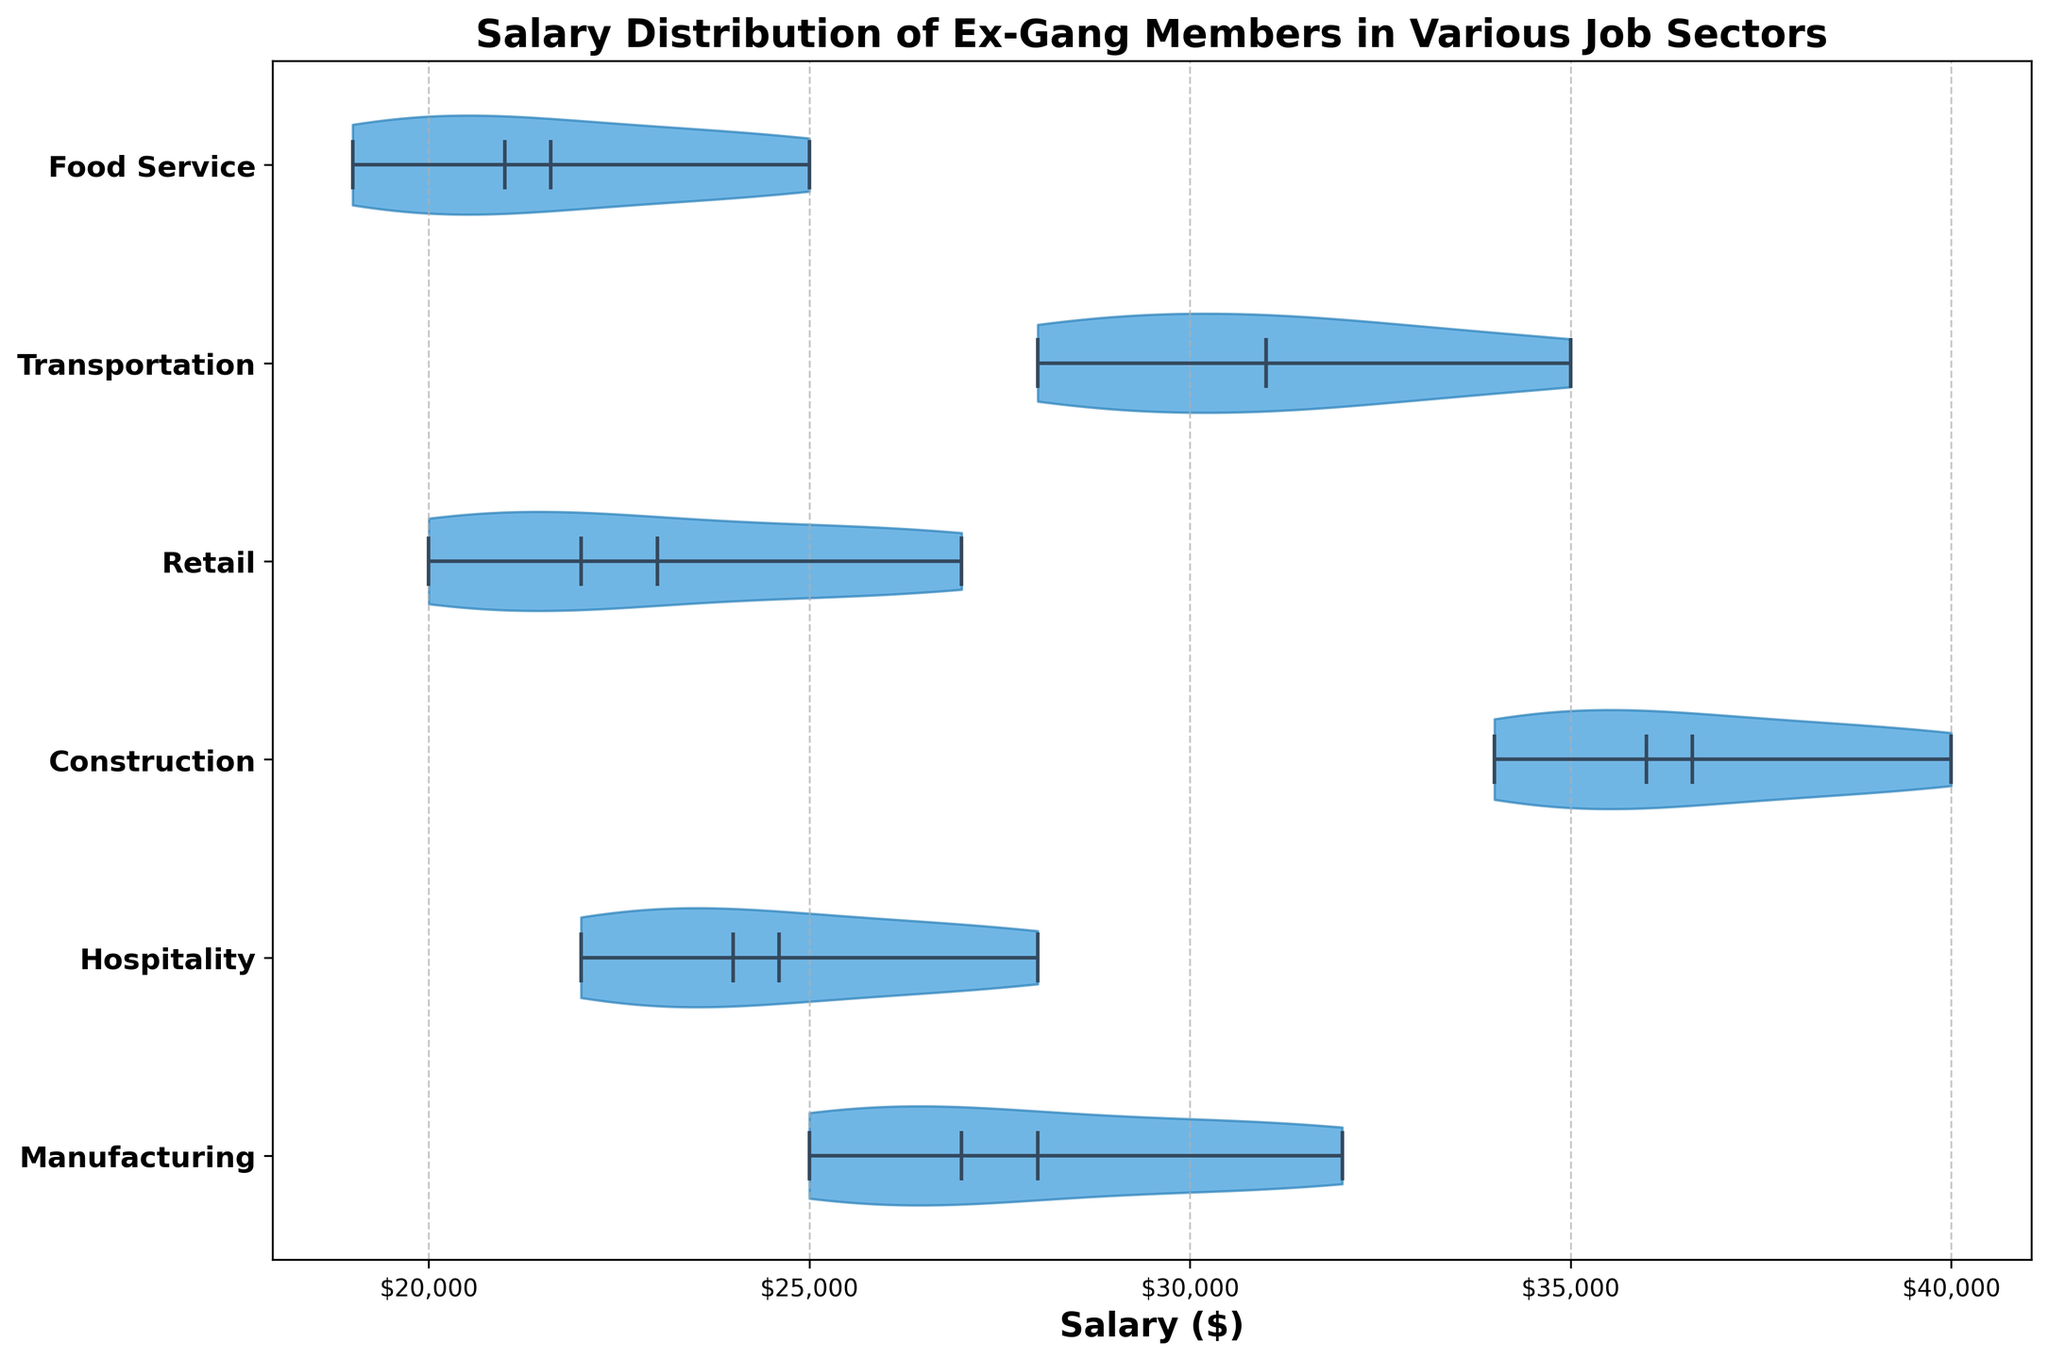What's the title of the figure? The title of the figure is usually displayed at the top, larger, and bolder than the other text elements.
Answer: Salary Distribution of Ex-Gang Members in Various Job Sectors What are the job sectors included in the figure? The text labels along the vertical axis indicate the different job sectors.
Answer: Manufacturing, Hospitality, Construction, Retail, Transportation, Food Service Which job sector has the highest median salary? The horizontal line inside the violin plot represents the median salary for each sector. Identify the longest horizontal line.
Answer: Construction Which job sector has the lowest median salary? Look for the shortest horizontal line among the violin plots to find the lowest median salary.
Answer: Food Service What can be observed about the spread of salaries in the Hospitality sector? The width of the violin plot shows salary distribution spread. A wider plot signifies more variation in salaries, while a narrow plot indicates less variation.
Answer: The spread is moderate What's the interquartile range (middle 50% of the data) of salaries in the Transportation sector? The thickest part of the violin plot reveals the interquartile range. For Transportation, it's the segment where the plot is widest. Observe both ends of this segment for precise values.
Answer: Approximately $29000 to $32000 Which job sector shows the most variation in salary distribution? The breadth of the violin plots signifies variation. The widest violin plot displays the most variation.
Answer: Construction Are the mean salaries higher in the Transportation or Hospitality sector? The mean salary is represented by the white dot inside each violin plot. Compare the positions of the dots in the Transportation and Hospitality sectors.
Answer: Transportation How do the median salaries in Retail compare to those in Food Service? Compare the horizontal lines (medians) in the violin plots for Retail and Food Service sectors.
Answer: Retail is higher 